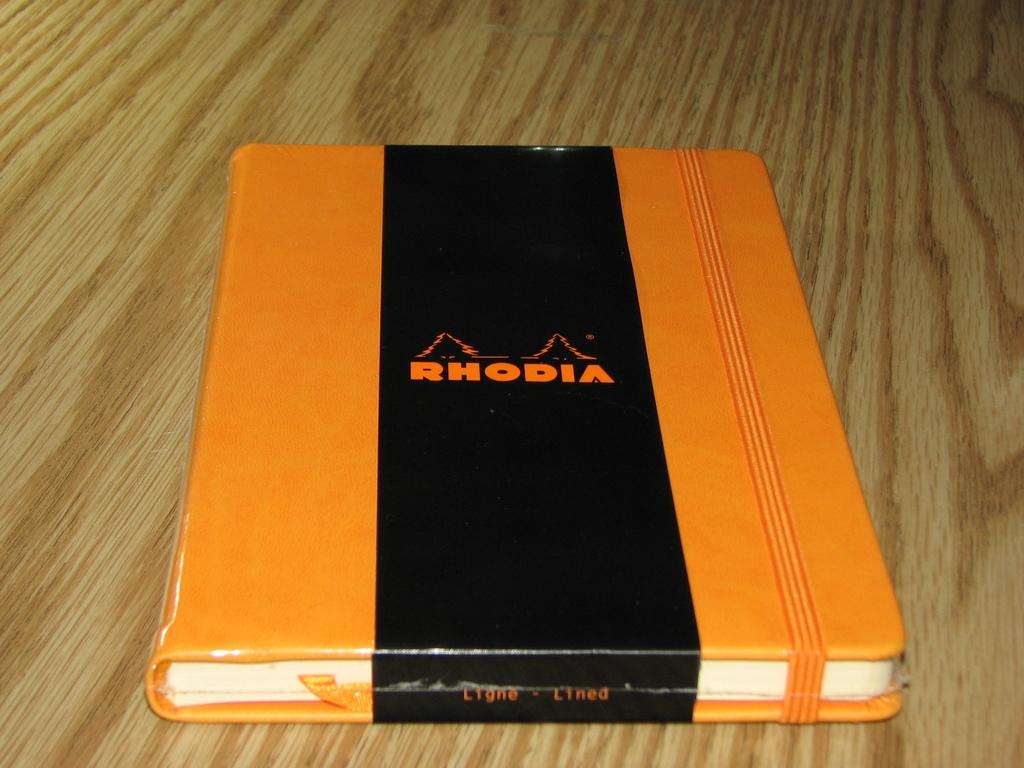Is the pages lined?
Ensure brevity in your answer.  Yes. 